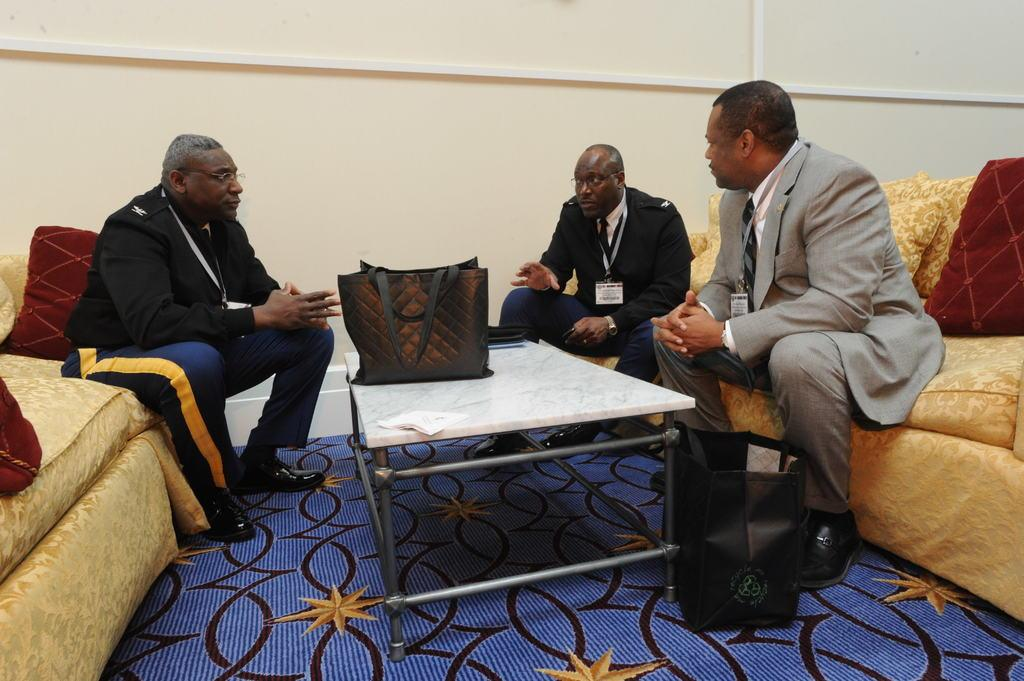How many people are in the image? There are three men in the image. What are the men doing in the image? The men are seated on a sofa and speaking to each other. Can you describe any objects in the image besides the men? Yes, there is a handbag on a table and at least two pillows in the image. What type of clam can be seen crawling on the sofa in the image? There are no clams present in the image; it features three men seated on a sofa and speaking to each other. 